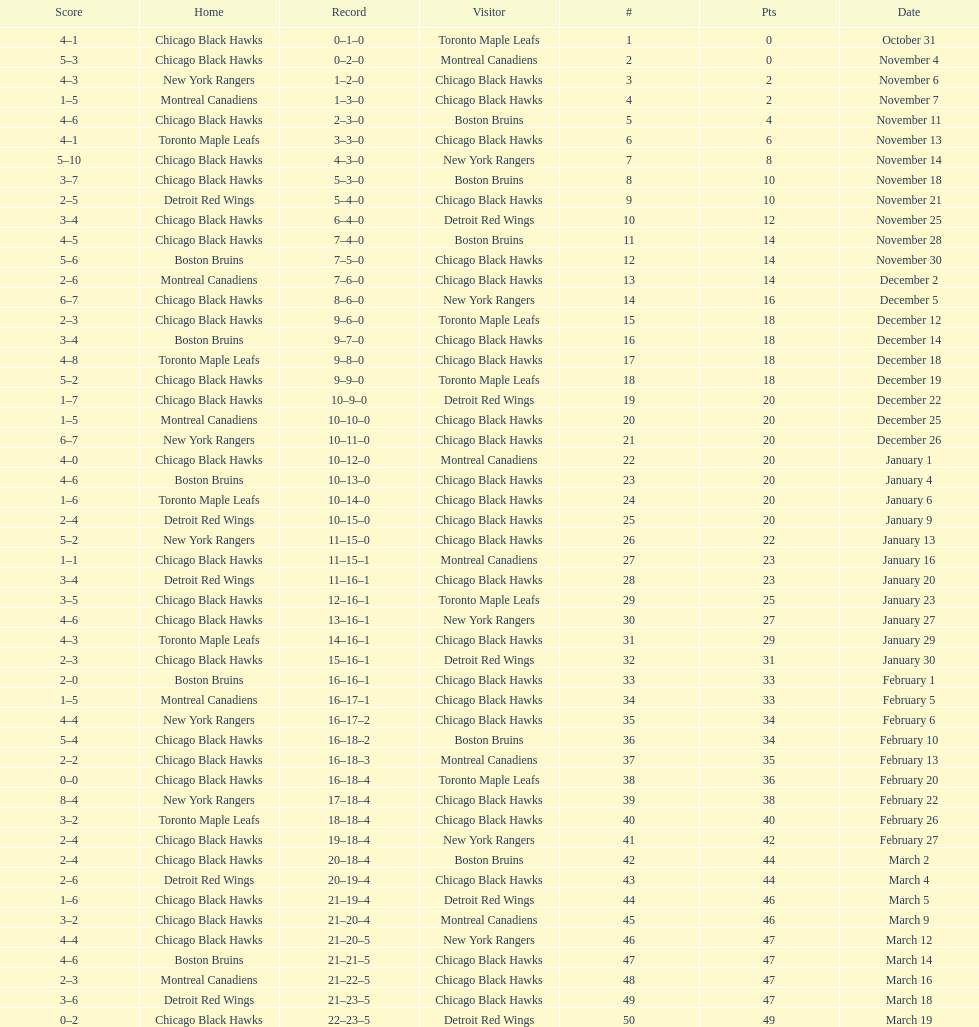What is was the difference in score in the december 19th win? 3. 